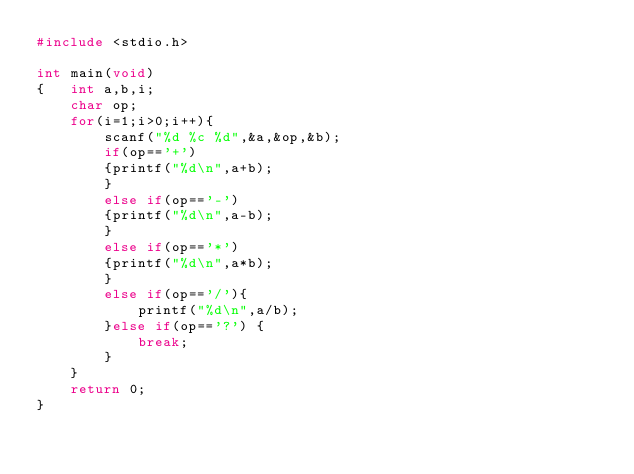<code> <loc_0><loc_0><loc_500><loc_500><_C_>#include <stdio.h>
  
int main(void)
{   int a,b,i;
    char op;
    for(i=1;i>0;i++){
        scanf("%d %c %d",&a,&op,&b);
        if(op=='+')
        {printf("%d\n",a+b);
        }
        else if(op=='-')
        {printf("%d\n",a-b);
        }
        else if(op=='*')
        {printf("%d\n",a*b);
        }
        else if(op=='/'){
            printf("%d\n",a/b);
        }else if(op=='?') {
            break;
        }
    }
    return 0;
}
</code> 